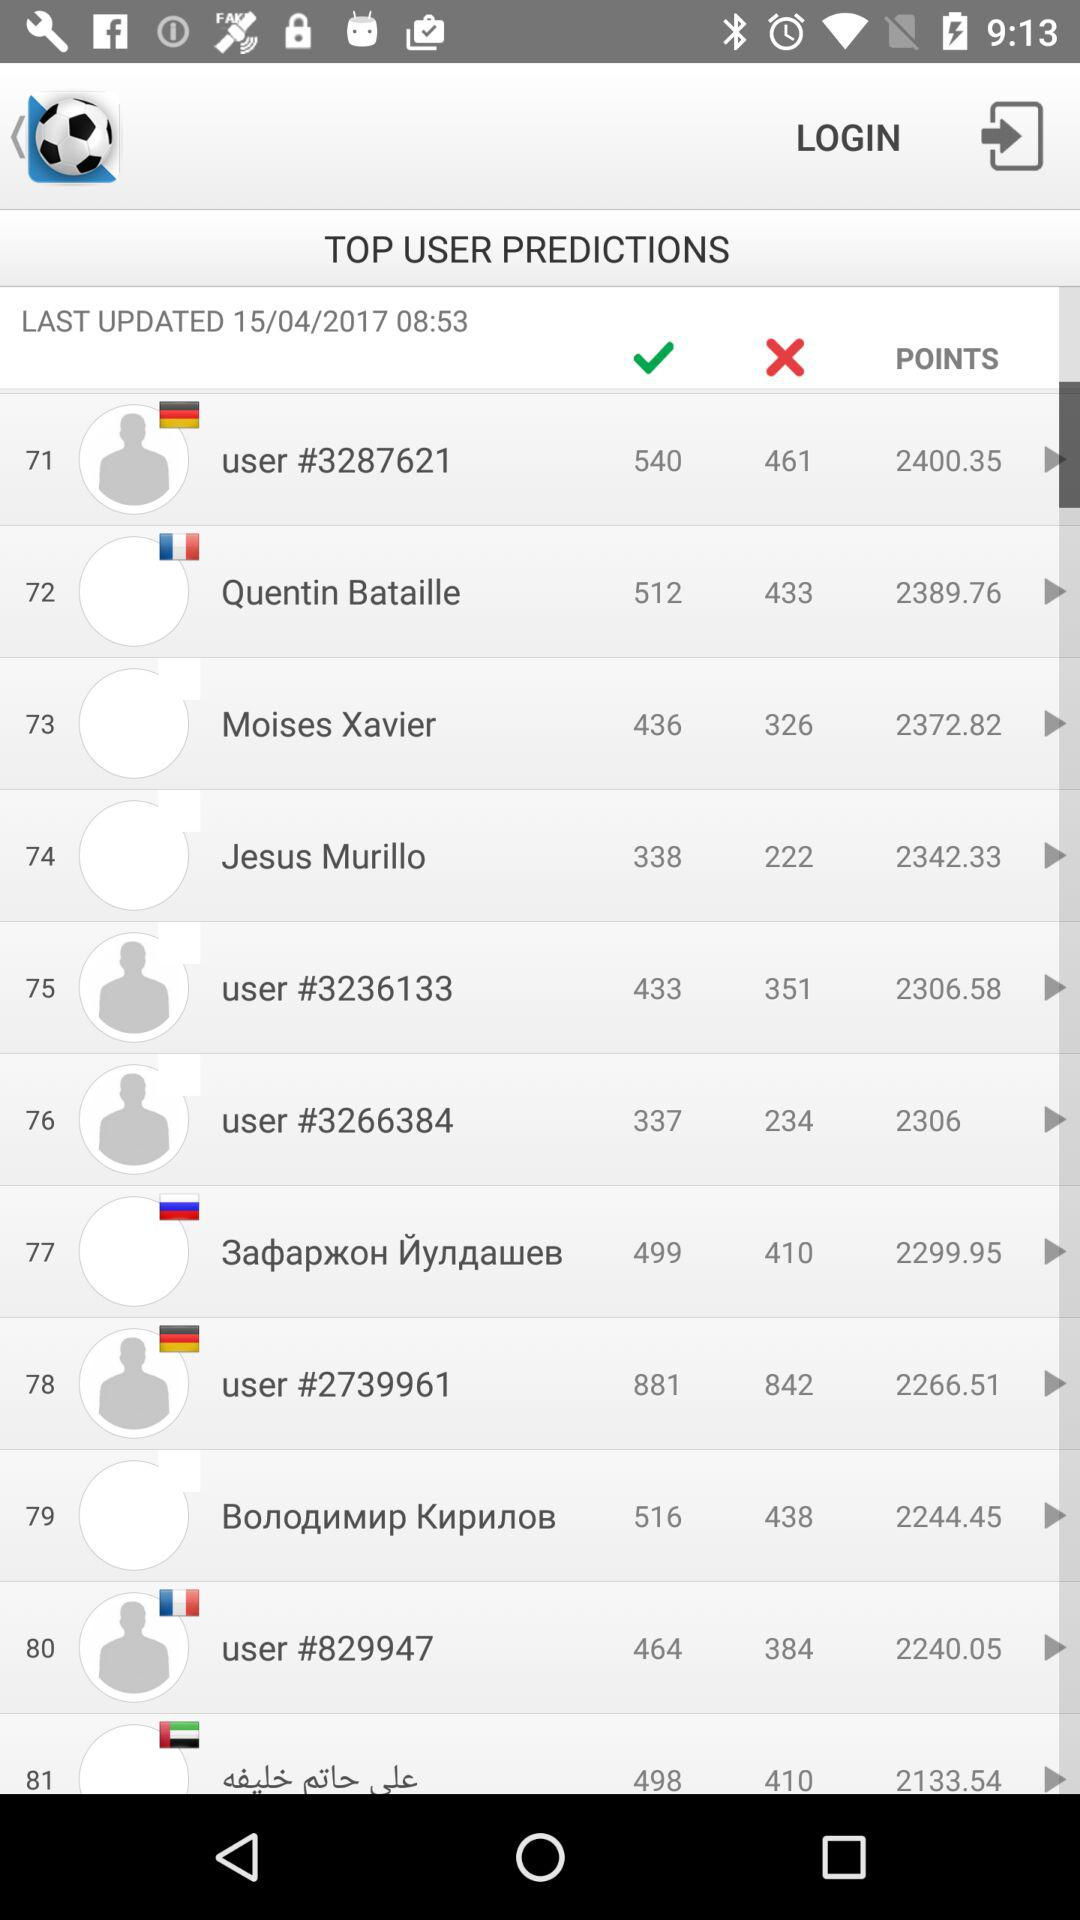How many points are there for Jesus Murillo? There are 2342.33 points. 